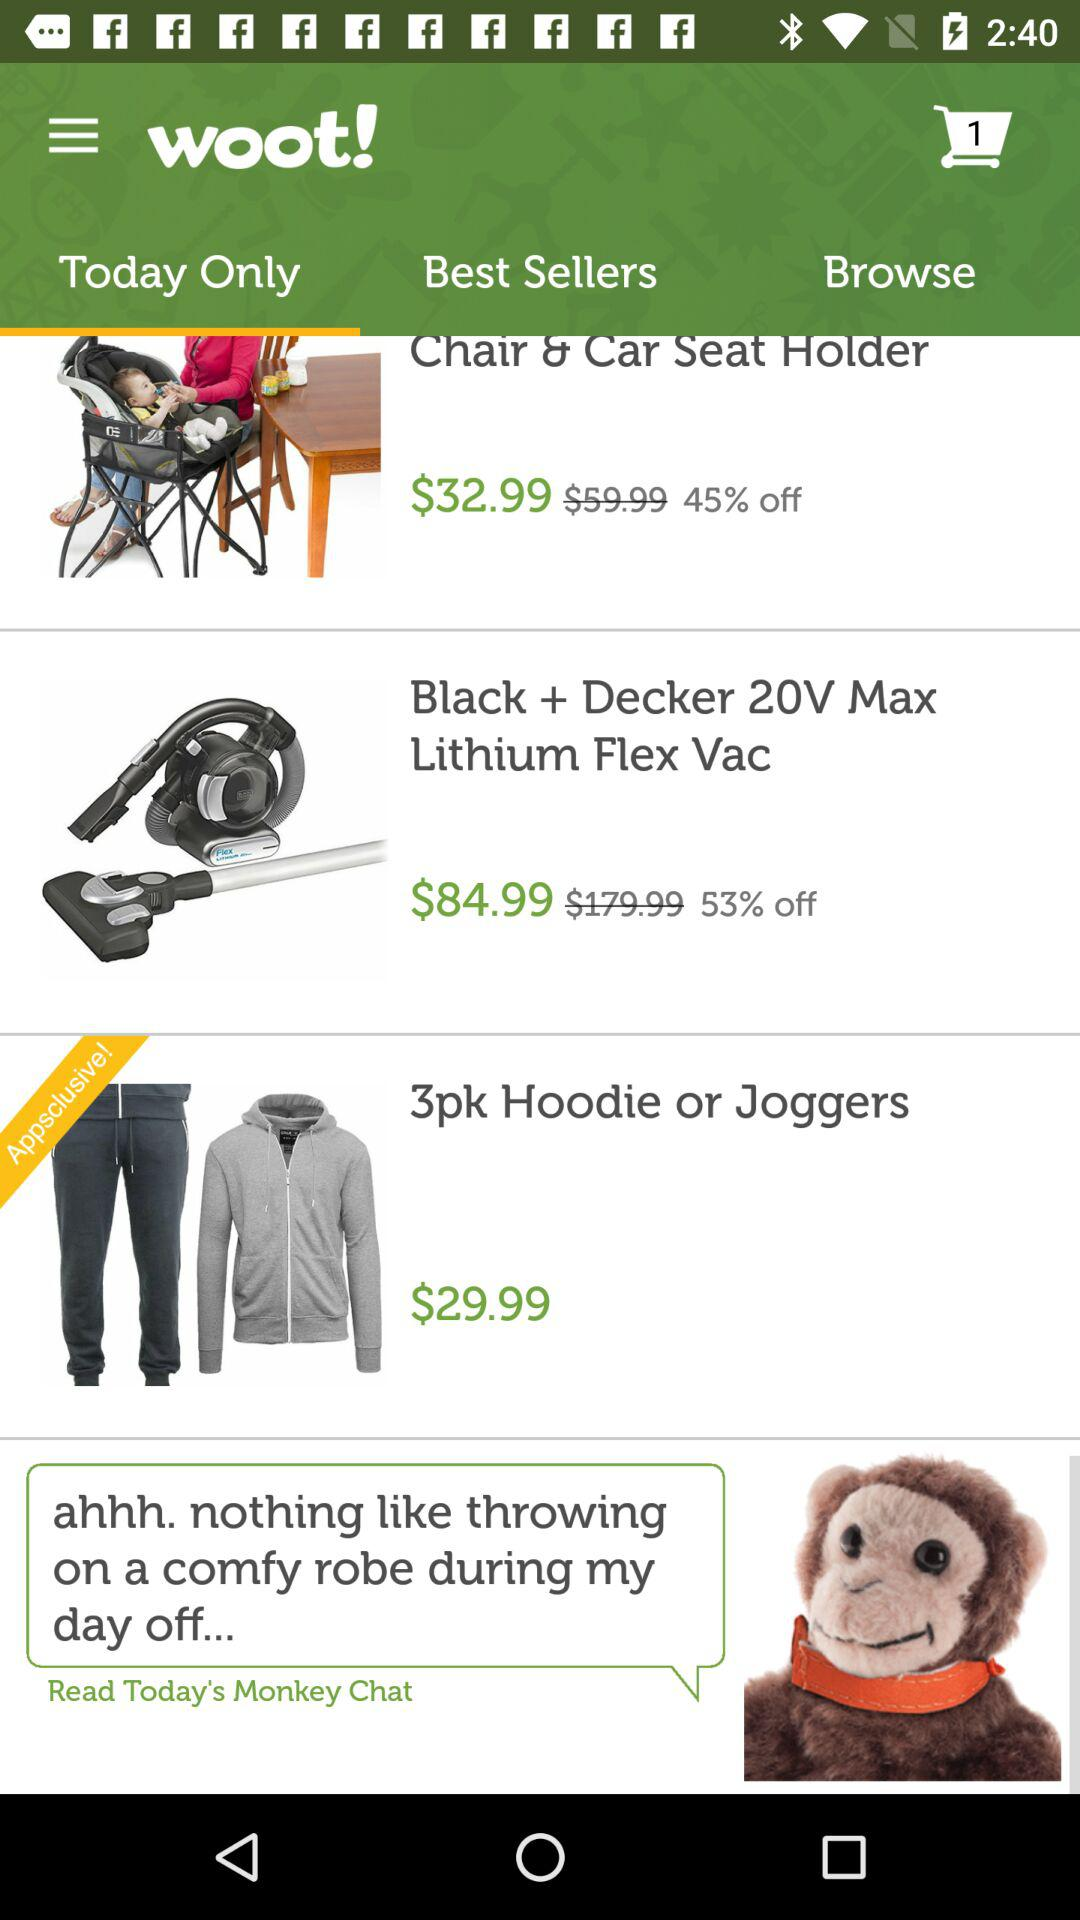What are the different items in "Today Only"? The different items are "Chair & Car Seat Holder", "Black + Decker 20V Max Lithium Flex Vac" and "3pk Hoodie or Joggers". 